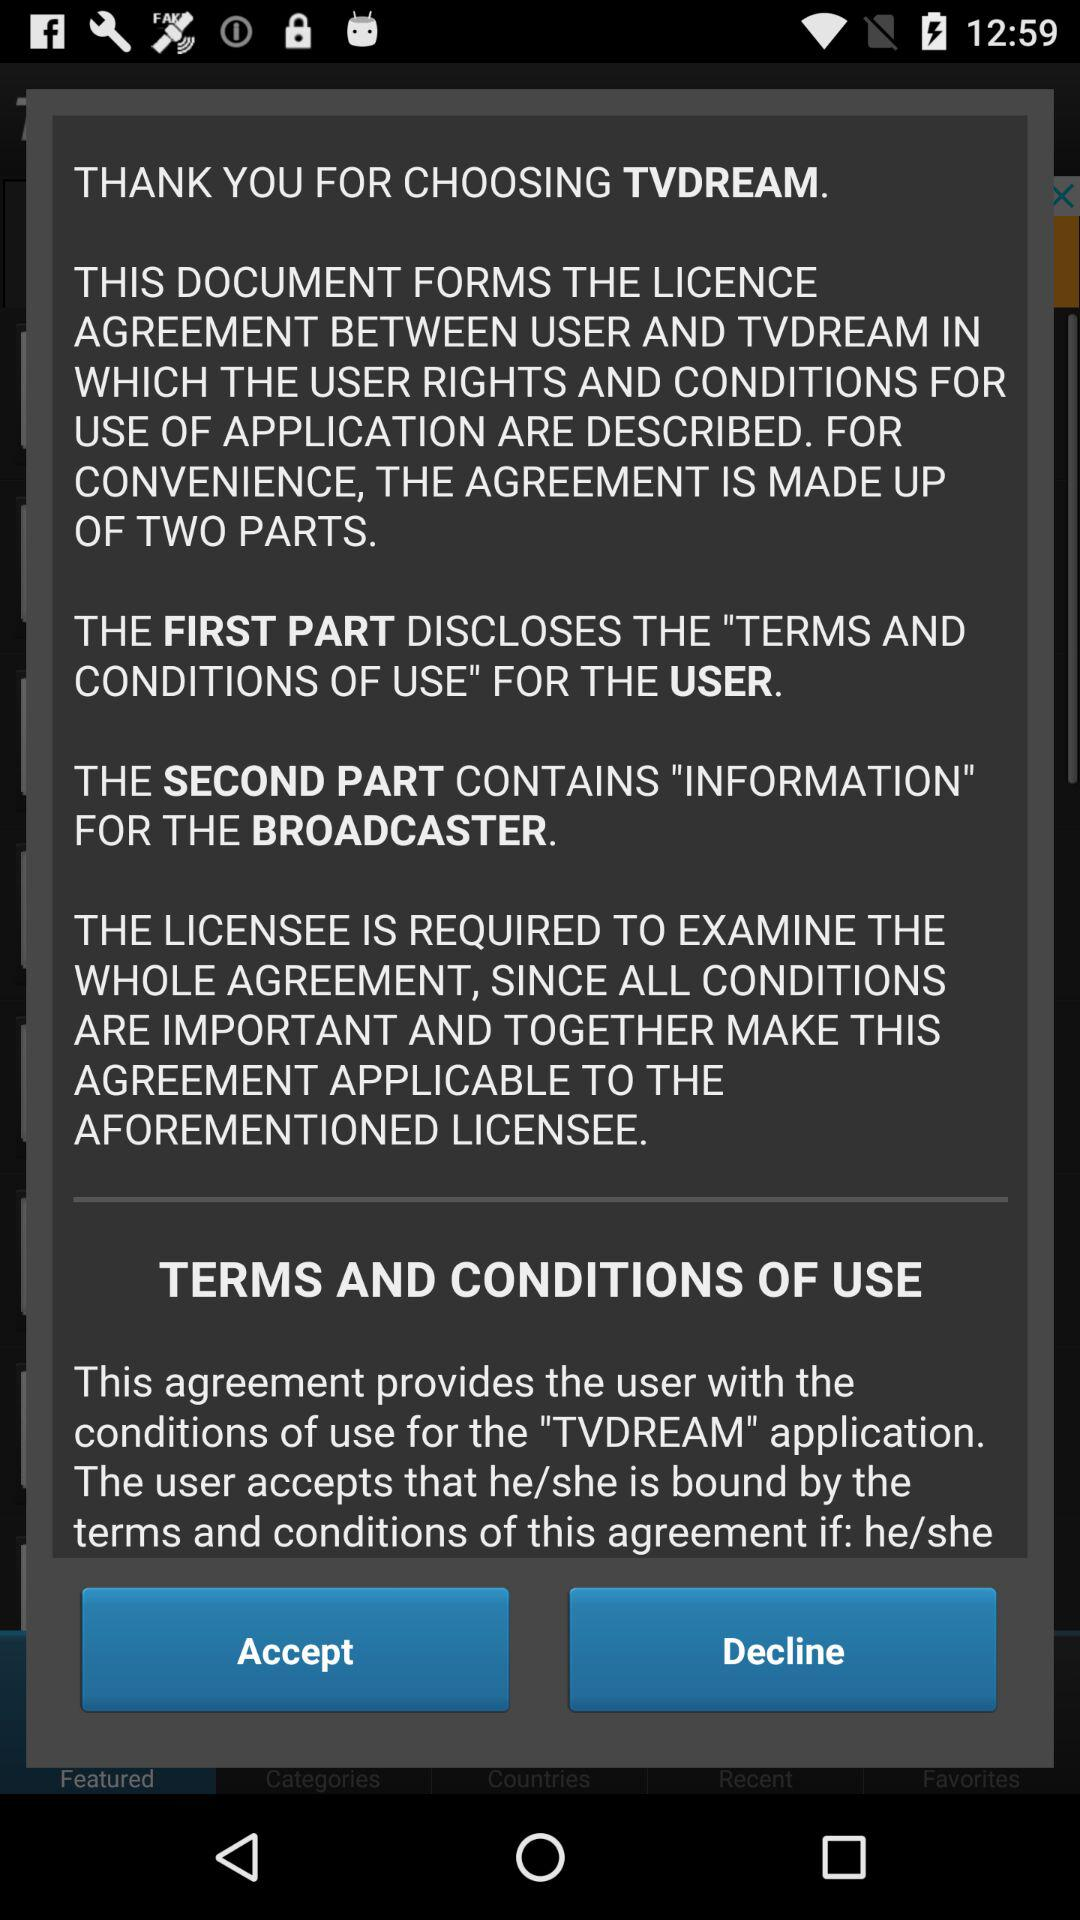What part contains the information about the broadcaster? The second part contains the information about the broadcaster. 